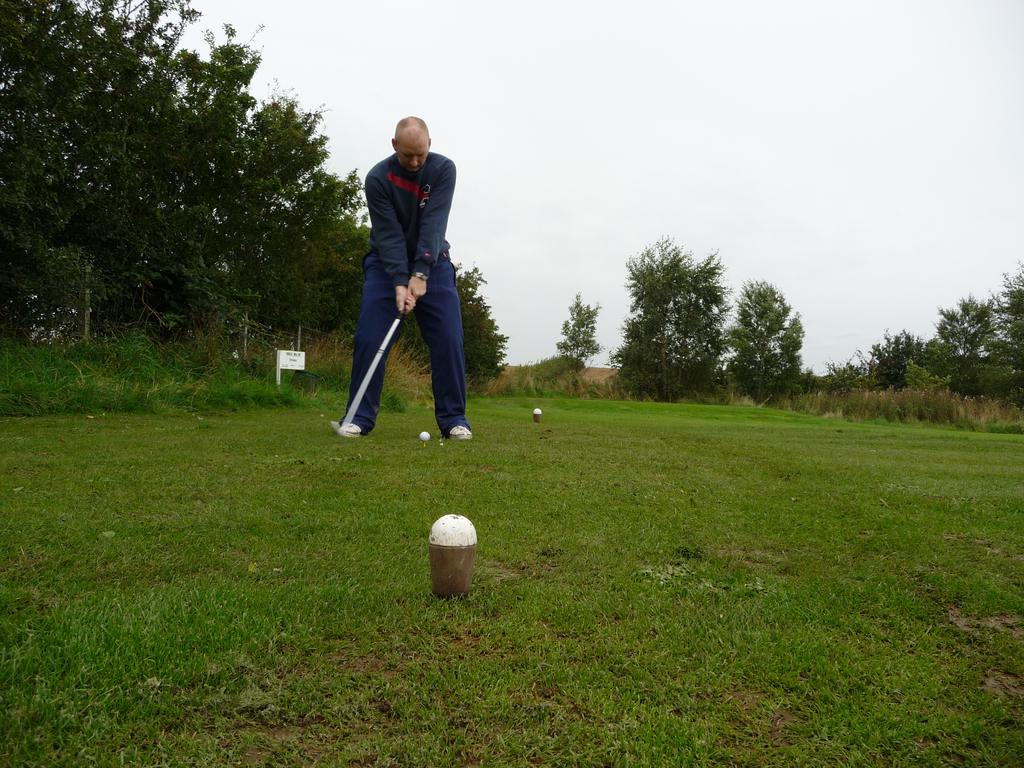What is the man in the image doing? The man is playing golf in the image. What color are the trousers the man is wearing? The man is wearing blue trousers. What can be seen on the left side of the image? There are trees on the left side of the image. How would you describe the sky in the image? The sky is cloudy in the image. What type of quiver is the man using to store his golf clubs in the image? There is no quiver present in the image, as golf clubs are typically carried in a golf bag. 